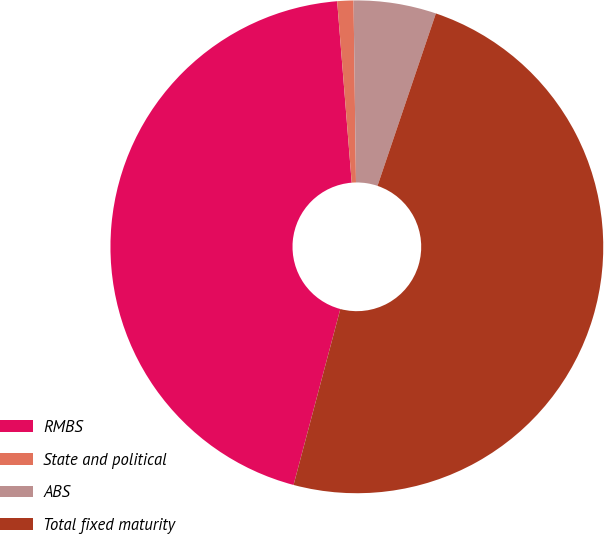<chart> <loc_0><loc_0><loc_500><loc_500><pie_chart><fcel>RMBS<fcel>State and political<fcel>ABS<fcel>Total fixed maturity<nl><fcel>44.59%<fcel>1.06%<fcel>5.41%<fcel>48.94%<nl></chart> 